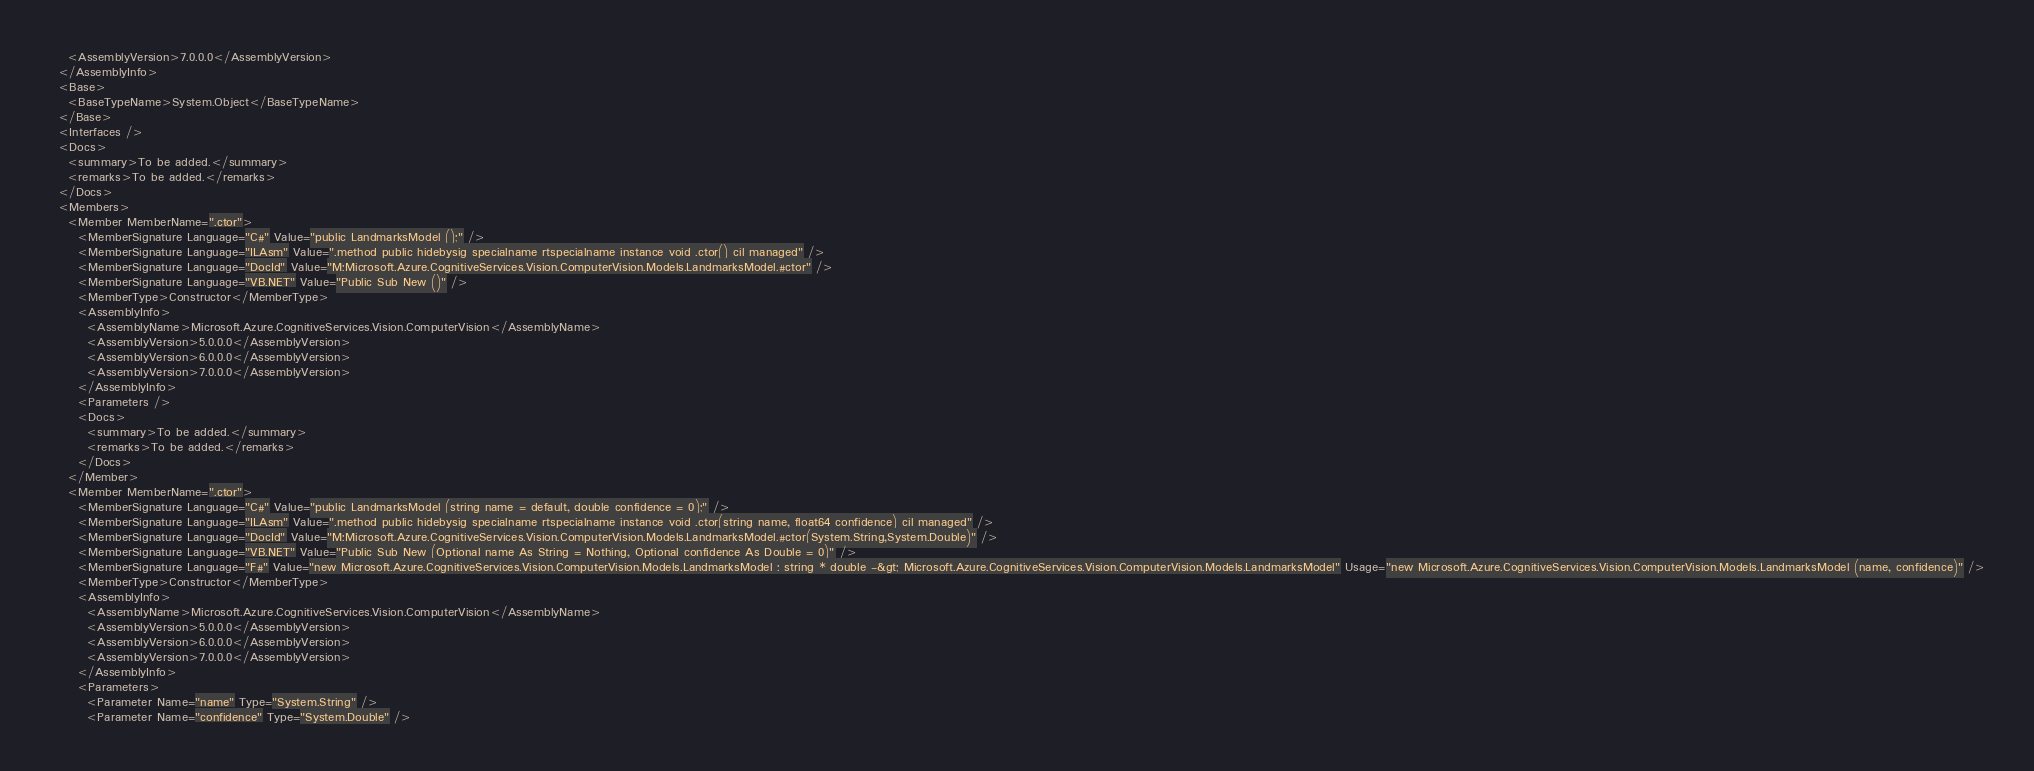Convert code to text. <code><loc_0><loc_0><loc_500><loc_500><_XML_>    <AssemblyVersion>7.0.0.0</AssemblyVersion>
  </AssemblyInfo>
  <Base>
    <BaseTypeName>System.Object</BaseTypeName>
  </Base>
  <Interfaces />
  <Docs>
    <summary>To be added.</summary>
    <remarks>To be added.</remarks>
  </Docs>
  <Members>
    <Member MemberName=".ctor">
      <MemberSignature Language="C#" Value="public LandmarksModel ();" />
      <MemberSignature Language="ILAsm" Value=".method public hidebysig specialname rtspecialname instance void .ctor() cil managed" />
      <MemberSignature Language="DocId" Value="M:Microsoft.Azure.CognitiveServices.Vision.ComputerVision.Models.LandmarksModel.#ctor" />
      <MemberSignature Language="VB.NET" Value="Public Sub New ()" />
      <MemberType>Constructor</MemberType>
      <AssemblyInfo>
        <AssemblyName>Microsoft.Azure.CognitiveServices.Vision.ComputerVision</AssemblyName>
        <AssemblyVersion>5.0.0.0</AssemblyVersion>
        <AssemblyVersion>6.0.0.0</AssemblyVersion>
        <AssemblyVersion>7.0.0.0</AssemblyVersion>
      </AssemblyInfo>
      <Parameters />
      <Docs>
        <summary>To be added.</summary>
        <remarks>To be added.</remarks>
      </Docs>
    </Member>
    <Member MemberName=".ctor">
      <MemberSignature Language="C#" Value="public LandmarksModel (string name = default, double confidence = 0);" />
      <MemberSignature Language="ILAsm" Value=".method public hidebysig specialname rtspecialname instance void .ctor(string name, float64 confidence) cil managed" />
      <MemberSignature Language="DocId" Value="M:Microsoft.Azure.CognitiveServices.Vision.ComputerVision.Models.LandmarksModel.#ctor(System.String,System.Double)" />
      <MemberSignature Language="VB.NET" Value="Public Sub New (Optional name As String = Nothing, Optional confidence As Double = 0)" />
      <MemberSignature Language="F#" Value="new Microsoft.Azure.CognitiveServices.Vision.ComputerVision.Models.LandmarksModel : string * double -&gt; Microsoft.Azure.CognitiveServices.Vision.ComputerVision.Models.LandmarksModel" Usage="new Microsoft.Azure.CognitiveServices.Vision.ComputerVision.Models.LandmarksModel (name, confidence)" />
      <MemberType>Constructor</MemberType>
      <AssemblyInfo>
        <AssemblyName>Microsoft.Azure.CognitiveServices.Vision.ComputerVision</AssemblyName>
        <AssemblyVersion>5.0.0.0</AssemblyVersion>
        <AssemblyVersion>6.0.0.0</AssemblyVersion>
        <AssemblyVersion>7.0.0.0</AssemblyVersion>
      </AssemblyInfo>
      <Parameters>
        <Parameter Name="name" Type="System.String" />
        <Parameter Name="confidence" Type="System.Double" /></code> 